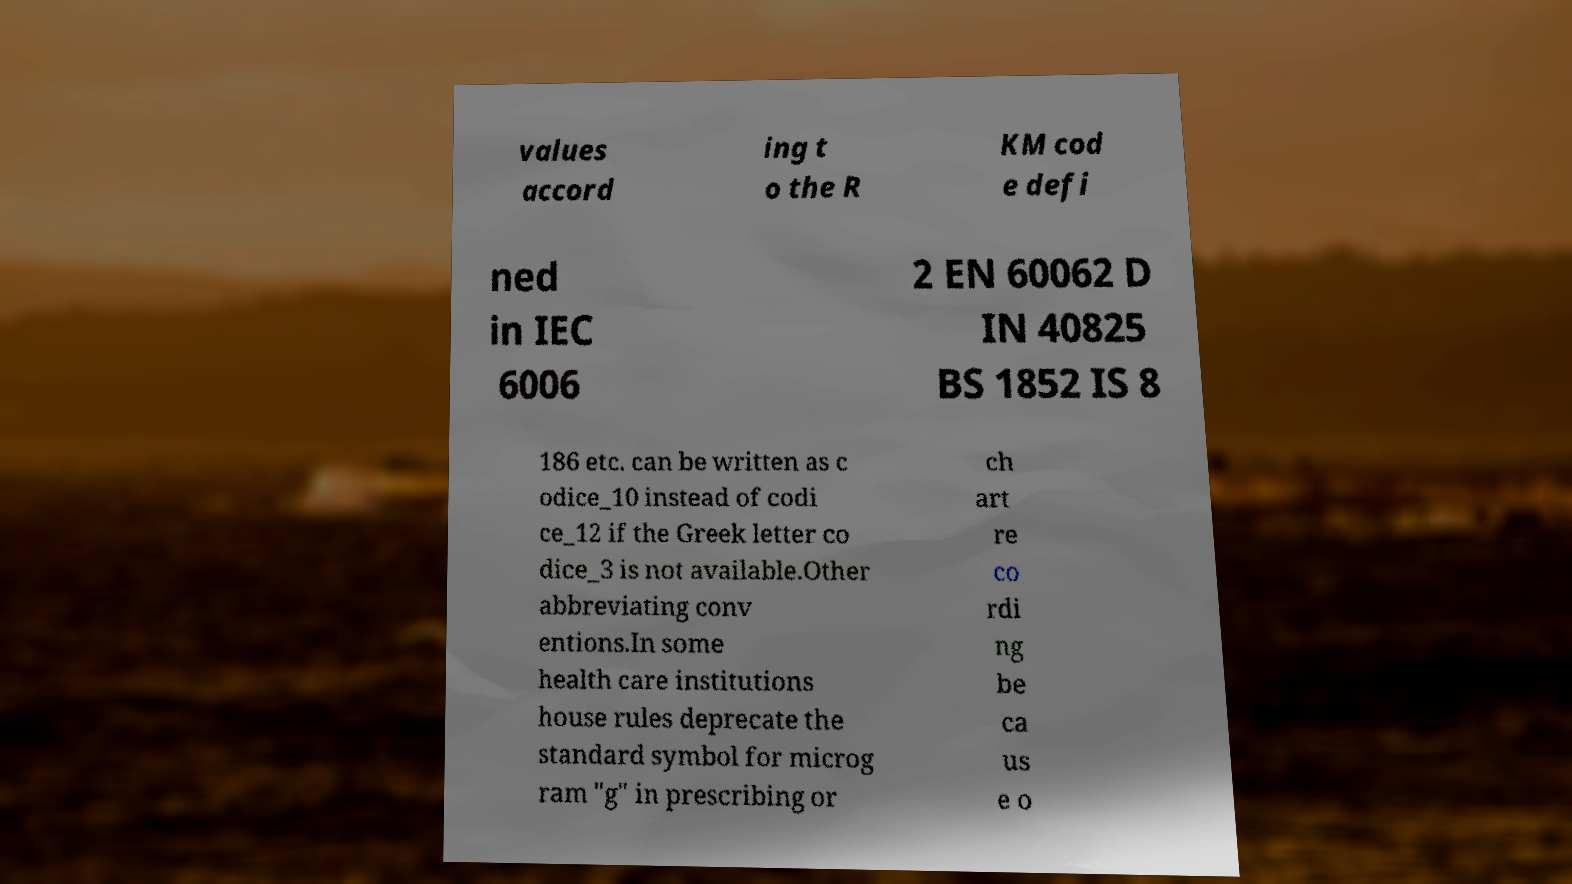There's text embedded in this image that I need extracted. Can you transcribe it verbatim? values accord ing t o the R KM cod e defi ned in IEC 6006 2 EN 60062 D IN 40825 BS 1852 IS 8 186 etc. can be written as c odice_10 instead of codi ce_12 if the Greek letter co dice_3 is not available.Other abbreviating conv entions.In some health care institutions house rules deprecate the standard symbol for microg ram "g" in prescribing or ch art re co rdi ng be ca us e o 